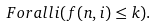Convert formula to latex. <formula><loc_0><loc_0><loc_500><loc_500>\ F o r a l l { i } ( f ( n , i ) \leq k ) .</formula> 